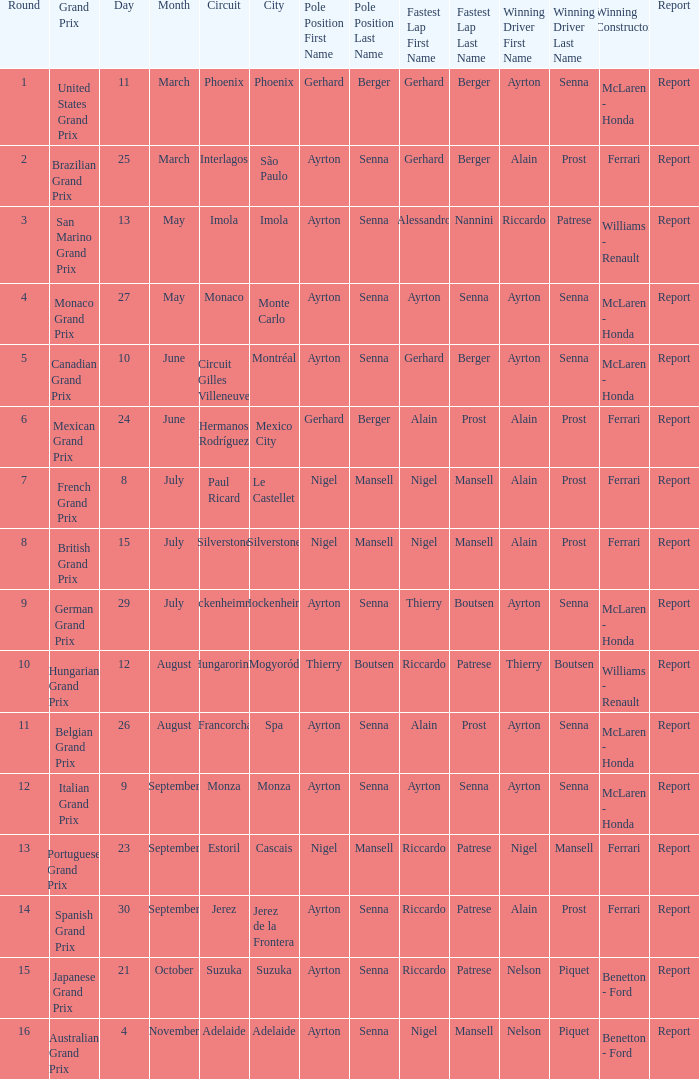What was the constructor when riccardo patrese was the winning driver? Williams - Renault. 